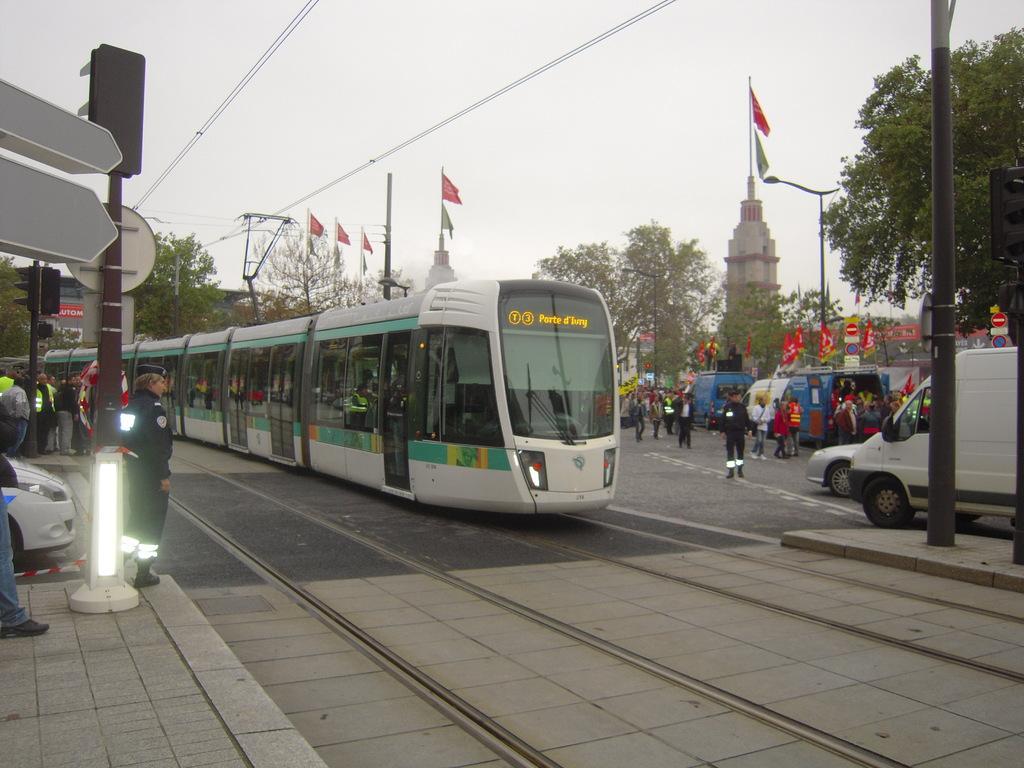How would you summarize this image in a sentence or two? In this picture, it looks like an electric locomotive. On the left and right side of the electric locomotive, there are groups of people and vehicles. Behind the locomotive, there are trees, cables, flags, architectures and the sky. On the left and right side of the image there are poles with boards and traffic signals attached to it. 